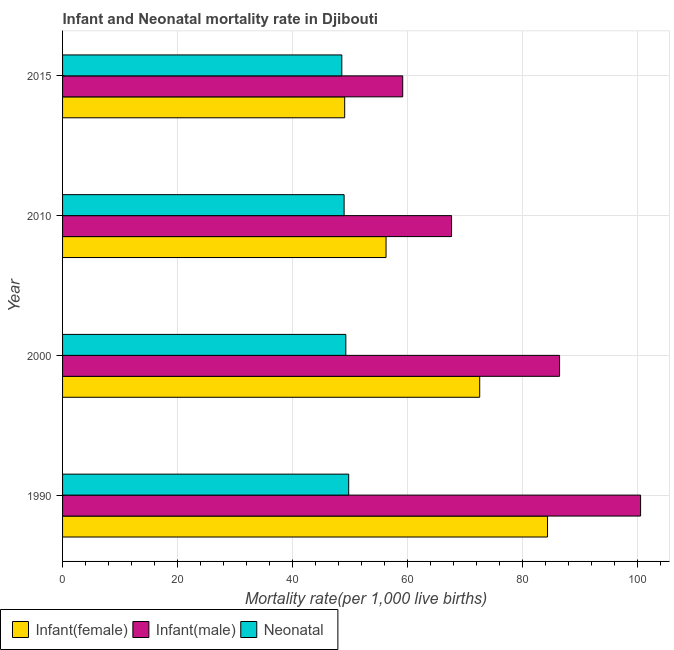How many different coloured bars are there?
Make the answer very short. 3. How many groups of bars are there?
Your response must be concise. 4. Are the number of bars per tick equal to the number of legend labels?
Ensure brevity in your answer.  Yes. How many bars are there on the 4th tick from the top?
Offer a terse response. 3. What is the neonatal mortality rate in 2010?
Provide a short and direct response. 49. Across all years, what is the maximum neonatal mortality rate?
Ensure brevity in your answer.  49.8. Across all years, what is the minimum neonatal mortality rate?
Provide a short and direct response. 48.6. In which year was the neonatal mortality rate minimum?
Give a very brief answer. 2015. What is the total infant mortality rate(female) in the graph?
Provide a short and direct response. 262.4. What is the difference between the infant mortality rate(male) in 1990 and the infant mortality rate(female) in 2015?
Provide a succinct answer. 51.5. What is the average infant mortality rate(male) per year?
Your answer should be very brief. 78.5. In how many years, is the infant mortality rate(female) greater than 56 ?
Your answer should be compact. 3. What is the ratio of the infant mortality rate(male) in 1990 to that in 2000?
Your response must be concise. 1.16. Is the infant mortality rate(male) in 1990 less than that in 2015?
Provide a short and direct response. No. What is the difference between the highest and the second highest infant mortality rate(female)?
Keep it short and to the point. 11.8. What is the difference between the highest and the lowest infant mortality rate(male)?
Offer a very short reply. 41.4. In how many years, is the infant mortality rate(male) greater than the average infant mortality rate(male) taken over all years?
Your answer should be compact. 2. What does the 3rd bar from the top in 2015 represents?
Your answer should be compact. Infant(female). What does the 2nd bar from the bottom in 2015 represents?
Provide a short and direct response. Infant(male). How many bars are there?
Provide a succinct answer. 12. Are the values on the major ticks of X-axis written in scientific E-notation?
Give a very brief answer. No. Where does the legend appear in the graph?
Your response must be concise. Bottom left. How are the legend labels stacked?
Provide a succinct answer. Horizontal. What is the title of the graph?
Keep it short and to the point. Infant and Neonatal mortality rate in Djibouti. Does "Unemployment benefits" appear as one of the legend labels in the graph?
Ensure brevity in your answer.  No. What is the label or title of the X-axis?
Provide a succinct answer. Mortality rate(per 1,0 live births). What is the Mortality rate(per 1,000 live births) in Infant(female) in 1990?
Offer a very short reply. 84.4. What is the Mortality rate(per 1,000 live births) of Infant(male) in 1990?
Ensure brevity in your answer.  100.6. What is the Mortality rate(per 1,000 live births) in Neonatal  in 1990?
Your response must be concise. 49.8. What is the Mortality rate(per 1,000 live births) of Infant(female) in 2000?
Ensure brevity in your answer.  72.6. What is the Mortality rate(per 1,000 live births) of Infant(male) in 2000?
Your response must be concise. 86.5. What is the Mortality rate(per 1,000 live births) in Neonatal  in 2000?
Give a very brief answer. 49.3. What is the Mortality rate(per 1,000 live births) in Infant(female) in 2010?
Ensure brevity in your answer.  56.3. What is the Mortality rate(per 1,000 live births) in Infant(male) in 2010?
Ensure brevity in your answer.  67.7. What is the Mortality rate(per 1,000 live births) in Infant(female) in 2015?
Offer a very short reply. 49.1. What is the Mortality rate(per 1,000 live births) in Infant(male) in 2015?
Your response must be concise. 59.2. What is the Mortality rate(per 1,000 live births) of Neonatal  in 2015?
Provide a succinct answer. 48.6. Across all years, what is the maximum Mortality rate(per 1,000 live births) of Infant(female)?
Provide a succinct answer. 84.4. Across all years, what is the maximum Mortality rate(per 1,000 live births) of Infant(male)?
Provide a short and direct response. 100.6. Across all years, what is the maximum Mortality rate(per 1,000 live births) of Neonatal ?
Offer a terse response. 49.8. Across all years, what is the minimum Mortality rate(per 1,000 live births) in Infant(female)?
Your answer should be very brief. 49.1. Across all years, what is the minimum Mortality rate(per 1,000 live births) in Infant(male)?
Provide a succinct answer. 59.2. Across all years, what is the minimum Mortality rate(per 1,000 live births) of Neonatal ?
Make the answer very short. 48.6. What is the total Mortality rate(per 1,000 live births) in Infant(female) in the graph?
Give a very brief answer. 262.4. What is the total Mortality rate(per 1,000 live births) of Infant(male) in the graph?
Provide a succinct answer. 314. What is the total Mortality rate(per 1,000 live births) of Neonatal  in the graph?
Your answer should be very brief. 196.7. What is the difference between the Mortality rate(per 1,000 live births) of Infant(female) in 1990 and that in 2000?
Your answer should be very brief. 11.8. What is the difference between the Mortality rate(per 1,000 live births) of Neonatal  in 1990 and that in 2000?
Provide a short and direct response. 0.5. What is the difference between the Mortality rate(per 1,000 live births) of Infant(female) in 1990 and that in 2010?
Your response must be concise. 28.1. What is the difference between the Mortality rate(per 1,000 live births) in Infant(male) in 1990 and that in 2010?
Give a very brief answer. 32.9. What is the difference between the Mortality rate(per 1,000 live births) of Infant(female) in 1990 and that in 2015?
Provide a succinct answer. 35.3. What is the difference between the Mortality rate(per 1,000 live births) in Infant(male) in 1990 and that in 2015?
Your answer should be very brief. 41.4. What is the difference between the Mortality rate(per 1,000 live births) in Neonatal  in 1990 and that in 2015?
Provide a short and direct response. 1.2. What is the difference between the Mortality rate(per 1,000 live births) of Infant(female) in 2000 and that in 2010?
Keep it short and to the point. 16.3. What is the difference between the Mortality rate(per 1,000 live births) in Infant(female) in 2000 and that in 2015?
Your response must be concise. 23.5. What is the difference between the Mortality rate(per 1,000 live births) in Infant(male) in 2000 and that in 2015?
Ensure brevity in your answer.  27.3. What is the difference between the Mortality rate(per 1,000 live births) of Neonatal  in 2000 and that in 2015?
Ensure brevity in your answer.  0.7. What is the difference between the Mortality rate(per 1,000 live births) of Infant(female) in 2010 and that in 2015?
Provide a succinct answer. 7.2. What is the difference between the Mortality rate(per 1,000 live births) in Infant(male) in 2010 and that in 2015?
Your answer should be compact. 8.5. What is the difference between the Mortality rate(per 1,000 live births) of Neonatal  in 2010 and that in 2015?
Give a very brief answer. 0.4. What is the difference between the Mortality rate(per 1,000 live births) of Infant(female) in 1990 and the Mortality rate(per 1,000 live births) of Neonatal  in 2000?
Offer a terse response. 35.1. What is the difference between the Mortality rate(per 1,000 live births) of Infant(male) in 1990 and the Mortality rate(per 1,000 live births) of Neonatal  in 2000?
Provide a short and direct response. 51.3. What is the difference between the Mortality rate(per 1,000 live births) in Infant(female) in 1990 and the Mortality rate(per 1,000 live births) in Infant(male) in 2010?
Keep it short and to the point. 16.7. What is the difference between the Mortality rate(per 1,000 live births) in Infant(female) in 1990 and the Mortality rate(per 1,000 live births) in Neonatal  in 2010?
Offer a terse response. 35.4. What is the difference between the Mortality rate(per 1,000 live births) in Infant(male) in 1990 and the Mortality rate(per 1,000 live births) in Neonatal  in 2010?
Make the answer very short. 51.6. What is the difference between the Mortality rate(per 1,000 live births) of Infant(female) in 1990 and the Mortality rate(per 1,000 live births) of Infant(male) in 2015?
Offer a terse response. 25.2. What is the difference between the Mortality rate(per 1,000 live births) of Infant(female) in 1990 and the Mortality rate(per 1,000 live births) of Neonatal  in 2015?
Make the answer very short. 35.8. What is the difference between the Mortality rate(per 1,000 live births) in Infant(male) in 1990 and the Mortality rate(per 1,000 live births) in Neonatal  in 2015?
Your answer should be compact. 52. What is the difference between the Mortality rate(per 1,000 live births) in Infant(female) in 2000 and the Mortality rate(per 1,000 live births) in Neonatal  in 2010?
Offer a terse response. 23.6. What is the difference between the Mortality rate(per 1,000 live births) of Infant(male) in 2000 and the Mortality rate(per 1,000 live births) of Neonatal  in 2010?
Give a very brief answer. 37.5. What is the difference between the Mortality rate(per 1,000 live births) in Infant(female) in 2000 and the Mortality rate(per 1,000 live births) in Infant(male) in 2015?
Give a very brief answer. 13.4. What is the difference between the Mortality rate(per 1,000 live births) of Infant(female) in 2000 and the Mortality rate(per 1,000 live births) of Neonatal  in 2015?
Ensure brevity in your answer.  24. What is the difference between the Mortality rate(per 1,000 live births) in Infant(male) in 2000 and the Mortality rate(per 1,000 live births) in Neonatal  in 2015?
Make the answer very short. 37.9. What is the difference between the Mortality rate(per 1,000 live births) of Infant(female) in 2010 and the Mortality rate(per 1,000 live births) of Infant(male) in 2015?
Give a very brief answer. -2.9. What is the average Mortality rate(per 1,000 live births) of Infant(female) per year?
Your answer should be compact. 65.6. What is the average Mortality rate(per 1,000 live births) of Infant(male) per year?
Give a very brief answer. 78.5. What is the average Mortality rate(per 1,000 live births) of Neonatal  per year?
Your answer should be very brief. 49.17. In the year 1990, what is the difference between the Mortality rate(per 1,000 live births) of Infant(female) and Mortality rate(per 1,000 live births) of Infant(male)?
Give a very brief answer. -16.2. In the year 1990, what is the difference between the Mortality rate(per 1,000 live births) of Infant(female) and Mortality rate(per 1,000 live births) of Neonatal ?
Give a very brief answer. 34.6. In the year 1990, what is the difference between the Mortality rate(per 1,000 live births) of Infant(male) and Mortality rate(per 1,000 live births) of Neonatal ?
Keep it short and to the point. 50.8. In the year 2000, what is the difference between the Mortality rate(per 1,000 live births) of Infant(female) and Mortality rate(per 1,000 live births) of Neonatal ?
Give a very brief answer. 23.3. In the year 2000, what is the difference between the Mortality rate(per 1,000 live births) of Infant(male) and Mortality rate(per 1,000 live births) of Neonatal ?
Make the answer very short. 37.2. In the year 2010, what is the difference between the Mortality rate(per 1,000 live births) in Infant(female) and Mortality rate(per 1,000 live births) in Neonatal ?
Keep it short and to the point. 7.3. In the year 2010, what is the difference between the Mortality rate(per 1,000 live births) in Infant(male) and Mortality rate(per 1,000 live births) in Neonatal ?
Ensure brevity in your answer.  18.7. In the year 2015, what is the difference between the Mortality rate(per 1,000 live births) of Infant(female) and Mortality rate(per 1,000 live births) of Infant(male)?
Your answer should be compact. -10.1. In the year 2015, what is the difference between the Mortality rate(per 1,000 live births) of Infant(female) and Mortality rate(per 1,000 live births) of Neonatal ?
Your answer should be very brief. 0.5. What is the ratio of the Mortality rate(per 1,000 live births) of Infant(female) in 1990 to that in 2000?
Your answer should be compact. 1.16. What is the ratio of the Mortality rate(per 1,000 live births) in Infant(male) in 1990 to that in 2000?
Your response must be concise. 1.16. What is the ratio of the Mortality rate(per 1,000 live births) of Neonatal  in 1990 to that in 2000?
Ensure brevity in your answer.  1.01. What is the ratio of the Mortality rate(per 1,000 live births) of Infant(female) in 1990 to that in 2010?
Offer a terse response. 1.5. What is the ratio of the Mortality rate(per 1,000 live births) of Infant(male) in 1990 to that in 2010?
Offer a terse response. 1.49. What is the ratio of the Mortality rate(per 1,000 live births) in Neonatal  in 1990 to that in 2010?
Provide a succinct answer. 1.02. What is the ratio of the Mortality rate(per 1,000 live births) of Infant(female) in 1990 to that in 2015?
Give a very brief answer. 1.72. What is the ratio of the Mortality rate(per 1,000 live births) in Infant(male) in 1990 to that in 2015?
Provide a short and direct response. 1.7. What is the ratio of the Mortality rate(per 1,000 live births) in Neonatal  in 1990 to that in 2015?
Keep it short and to the point. 1.02. What is the ratio of the Mortality rate(per 1,000 live births) of Infant(female) in 2000 to that in 2010?
Offer a terse response. 1.29. What is the ratio of the Mortality rate(per 1,000 live births) in Infant(male) in 2000 to that in 2010?
Your answer should be very brief. 1.28. What is the ratio of the Mortality rate(per 1,000 live births) in Infant(female) in 2000 to that in 2015?
Your answer should be very brief. 1.48. What is the ratio of the Mortality rate(per 1,000 live births) in Infant(male) in 2000 to that in 2015?
Your answer should be compact. 1.46. What is the ratio of the Mortality rate(per 1,000 live births) of Neonatal  in 2000 to that in 2015?
Ensure brevity in your answer.  1.01. What is the ratio of the Mortality rate(per 1,000 live births) in Infant(female) in 2010 to that in 2015?
Offer a terse response. 1.15. What is the ratio of the Mortality rate(per 1,000 live births) of Infant(male) in 2010 to that in 2015?
Ensure brevity in your answer.  1.14. What is the ratio of the Mortality rate(per 1,000 live births) in Neonatal  in 2010 to that in 2015?
Give a very brief answer. 1.01. What is the difference between the highest and the second highest Mortality rate(per 1,000 live births) in Infant(female)?
Provide a short and direct response. 11.8. What is the difference between the highest and the second highest Mortality rate(per 1,000 live births) in Infant(male)?
Provide a succinct answer. 14.1. What is the difference between the highest and the second highest Mortality rate(per 1,000 live births) in Neonatal ?
Your answer should be compact. 0.5. What is the difference between the highest and the lowest Mortality rate(per 1,000 live births) in Infant(female)?
Your response must be concise. 35.3. What is the difference between the highest and the lowest Mortality rate(per 1,000 live births) in Infant(male)?
Provide a short and direct response. 41.4. What is the difference between the highest and the lowest Mortality rate(per 1,000 live births) in Neonatal ?
Offer a terse response. 1.2. 